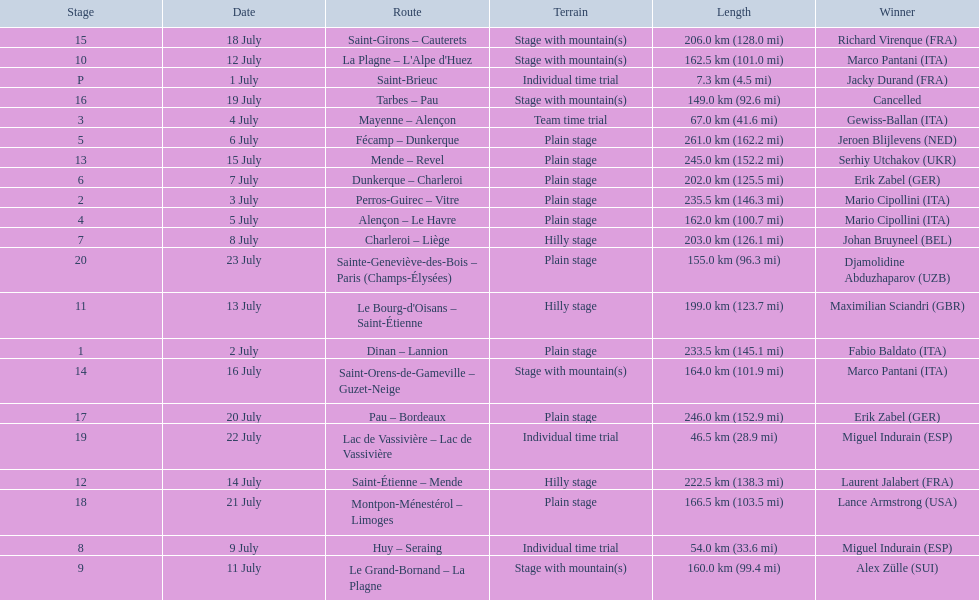What were the dates of the 1995 tour de france? 1 July, 2 July, 3 July, 4 July, 5 July, 6 July, 7 July, 8 July, 9 July, 11 July, 12 July, 13 July, 14 July, 15 July, 16 July, 18 July, 19 July, 20 July, 21 July, 22 July, 23 July. What was the length for july 8th? 203.0 km (126.1 mi). 